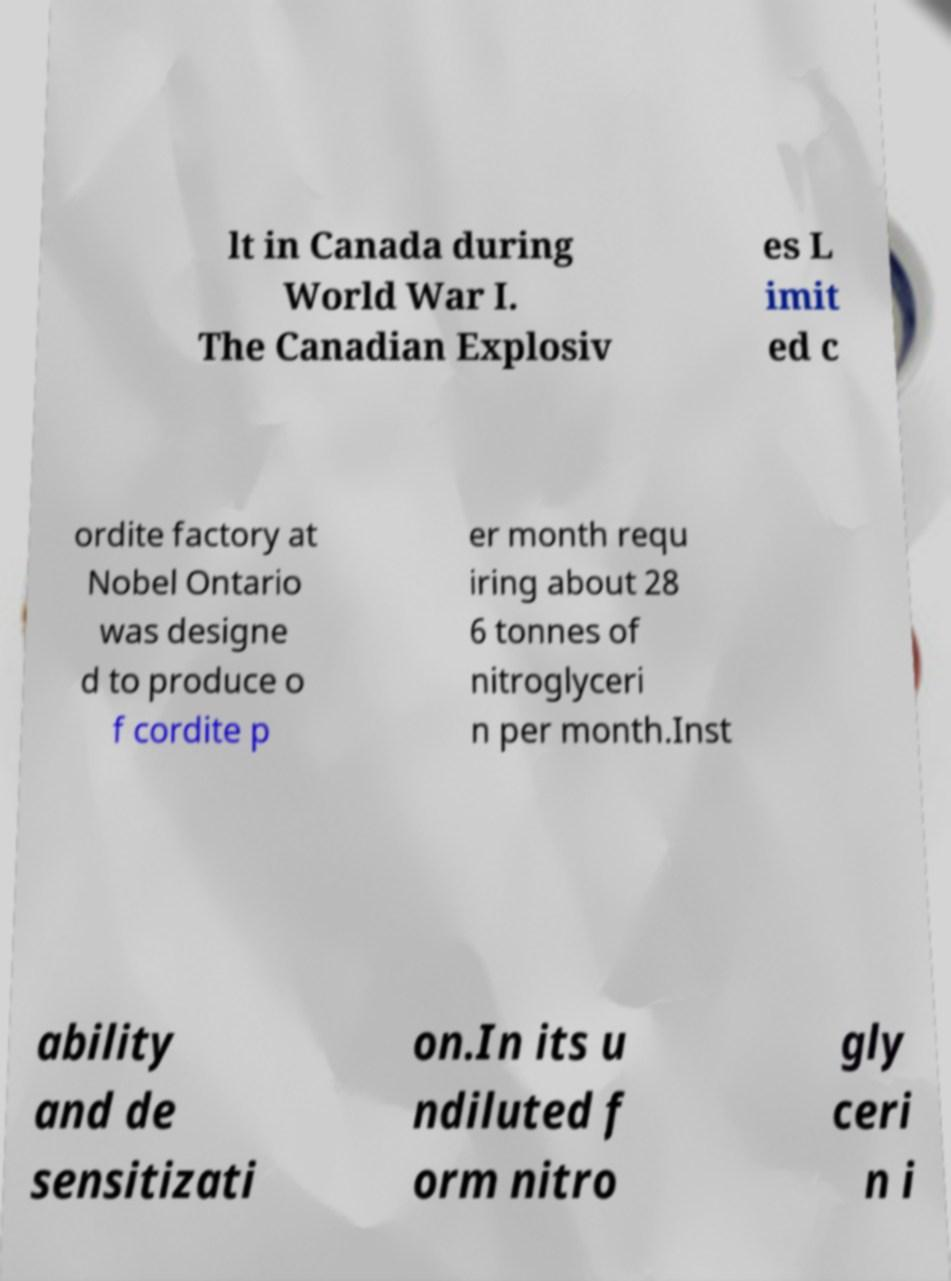Could you assist in decoding the text presented in this image and type it out clearly? lt in Canada during World War I. The Canadian Explosiv es L imit ed c ordite factory at Nobel Ontario was designe d to produce o f cordite p er month requ iring about 28 6 tonnes of nitroglyceri n per month.Inst ability and de sensitizati on.In its u ndiluted f orm nitro gly ceri n i 